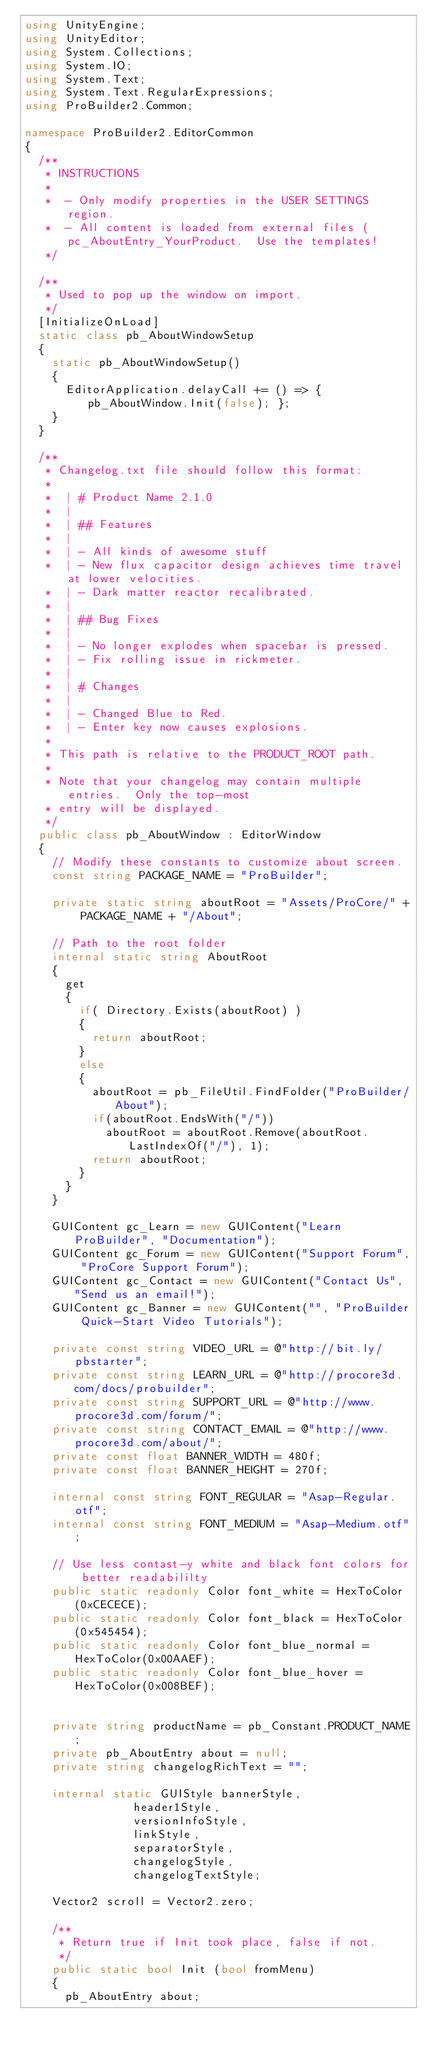<code> <loc_0><loc_0><loc_500><loc_500><_C#_>using UnityEngine;
using UnityEditor;
using System.Collections;
using System.IO;
using System.Text;
using System.Text.RegularExpressions;
using ProBuilder2.Common;

namespace ProBuilder2.EditorCommon
{
	/**
	 * INSTRUCTIONS
	 *
	 *  - Only modify properties in the USER SETTINGS region.
	 *	- All content is loaded from external files (pc_AboutEntry_YourProduct.  Use the templates!
	 */

	/**
	 * Used to pop up the window on import.
	 */
	[InitializeOnLoad]
	static class pb_AboutWindowSetup
	{
		static pb_AboutWindowSetup()
		{
			EditorApplication.delayCall += () => { pb_AboutWindow.Init(false); };
		}
	}

	/**
	 * Changelog.txt file should follow this format:
	 *
	 *	| # Product Name 2.1.0
	 *	|
	 *	| ## Features
	 *	|
	 *	| - All kinds of awesome stuff
	 *	| - New flux capacitor design achieves time travel at lower velocities.
	 *	| - Dark matter reactor recalibrated.
	 *	|
	 *	| ## Bug Fixes
	 *	|
	 *	| - No longer explodes when spacebar is pressed.
	 *	| - Fix rolling issue in rickmeter.
	 *	|
	 *	| # Changes
	 *	|
	 *	| - Changed Blue to Red.
	 *	| - Enter key now causes explosions.
	 *
	 * This path is relative to the PRODUCT_ROOT path.
	 *
	 * Note that your changelog may contain multiple entries.  Only the top-most
	 * entry will be displayed.
	 */
	public class pb_AboutWindow : EditorWindow
	{
		// Modify these constants to customize about screen.
	 	const string PACKAGE_NAME = "ProBuilder";

 		private static string aboutRoot = "Assets/ProCore/" + PACKAGE_NAME + "/About";

		// Path to the root folder
		internal static string AboutRoot
		{
			get
			{
				if( Directory.Exists(aboutRoot) )
				{
					return aboutRoot;
				}
				else
				{
					aboutRoot = pb_FileUtil.FindFolder("ProBuilder/About");
					if(aboutRoot.EndsWith("/"))
						aboutRoot = aboutRoot.Remove(aboutRoot.LastIndexOf("/"), 1);
					return aboutRoot;
				}
			}
		}

		GUIContent gc_Learn = new GUIContent("Learn ProBuilder", "Documentation");
		GUIContent gc_Forum = new GUIContent("Support Forum", "ProCore Support Forum");
		GUIContent gc_Contact = new GUIContent("Contact Us", "Send us an email!");
		GUIContent gc_Banner = new GUIContent("", "ProBuilder Quick-Start Video Tutorials");

		private const string VIDEO_URL = @"http://bit.ly/pbstarter";
		private const string LEARN_URL = @"http://procore3d.com/docs/probuilder";
		private const string SUPPORT_URL = @"http://www.procore3d.com/forum/";
		private const string CONTACT_EMAIL = @"http://www.procore3d.com/about/";
		private const float BANNER_WIDTH = 480f;
		private const float BANNER_HEIGHT = 270f;

		internal const string FONT_REGULAR = "Asap-Regular.otf";
		internal const string FONT_MEDIUM = "Asap-Medium.otf";

		// Use less contast-y white and black font colors for better readabililty
		public static readonly Color font_white = HexToColor(0xCECECE);
		public static readonly Color font_black = HexToColor(0x545454);
		public static readonly Color font_blue_normal = HexToColor(0x00AAEF);
		public static readonly Color font_blue_hover = HexToColor(0x008BEF);


		private string productName = pb_Constant.PRODUCT_NAME;
		private pb_AboutEntry about = null;
		private string changelogRichText = "";

		internal static GUIStyle bannerStyle,
								header1Style,
								versionInfoStyle,
								linkStyle,
								separatorStyle,
								changelogStyle,
								changelogTextStyle;

		Vector2 scroll = Vector2.zero;

		/**
		 * Return true if Init took place, false if not.
		 */
		public static bool Init (bool fromMenu)
		{
			pb_AboutEntry about;
</code> 